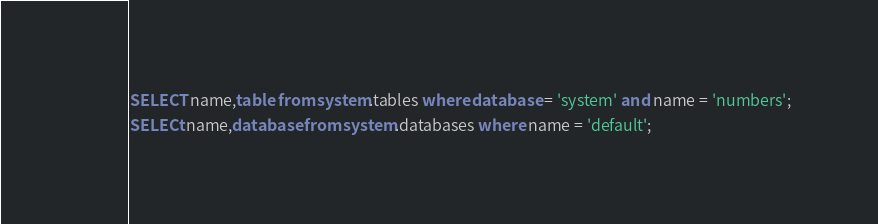<code> <loc_0><loc_0><loc_500><loc_500><_SQL_>SELECT name,table from system.tables where database = 'system' and name = 'numbers';
SELECt name,database from system.databases where name = 'default';
</code> 